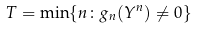<formula> <loc_0><loc_0><loc_500><loc_500>T = \min \{ n \colon g _ { n } ( Y ^ { n } ) \neq 0 \}</formula> 